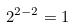<formula> <loc_0><loc_0><loc_500><loc_500>2 ^ { 2 - 2 } = 1</formula> 